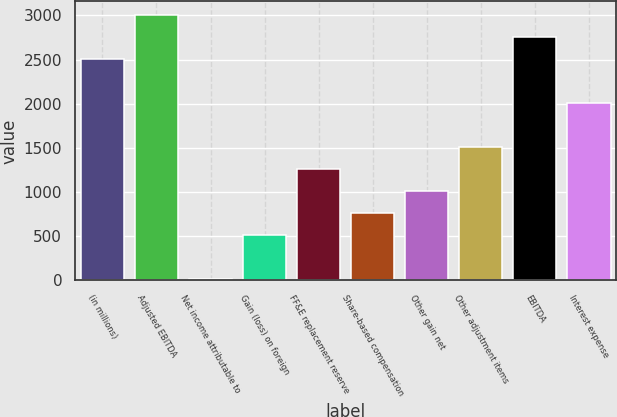<chart> <loc_0><loc_0><loc_500><loc_500><bar_chart><fcel>(in millions)<fcel>Adjusted EBITDA<fcel>Net income attributable to<fcel>Gain (loss) on foreign<fcel>FF&E replacement reserve<fcel>Share-based compensation<fcel>Other gain net<fcel>Other adjustment items<fcel>EBITDA<fcel>Interest expense<nl><fcel>2508<fcel>3007.8<fcel>9<fcel>508.8<fcel>1258.5<fcel>758.7<fcel>1008.6<fcel>1508.4<fcel>2757.9<fcel>2008.2<nl></chart> 